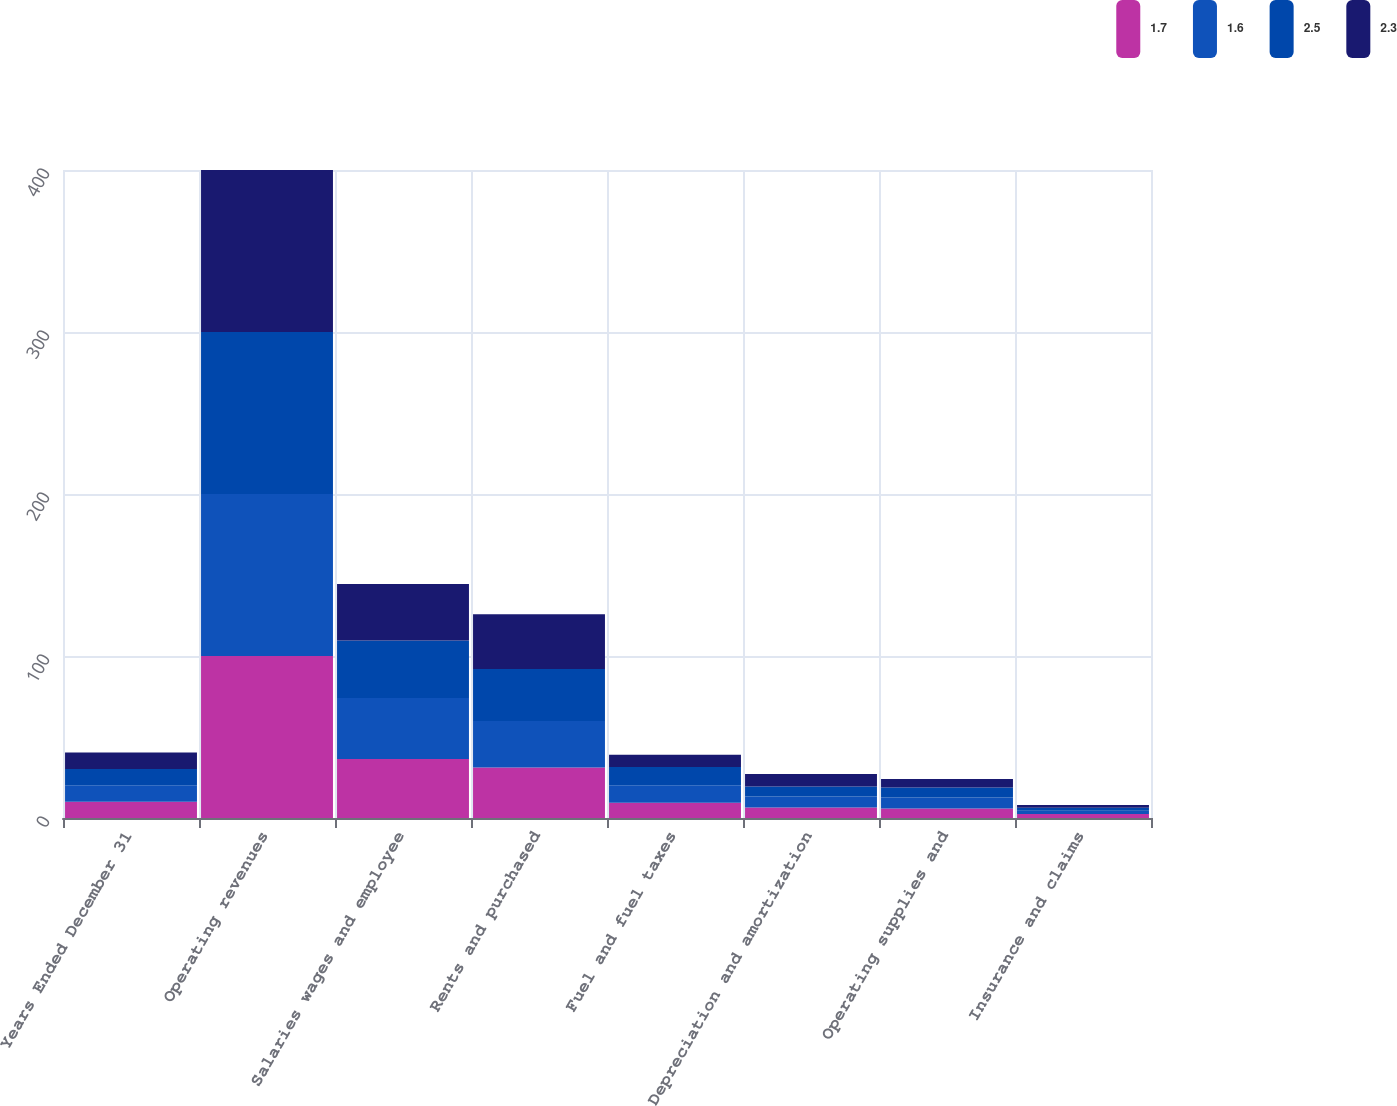<chart> <loc_0><loc_0><loc_500><loc_500><stacked_bar_chart><ecel><fcel>Years Ended December 31<fcel>Operating revenues<fcel>Salaries wages and employee<fcel>Rents and purchased<fcel>Fuel and fuel taxes<fcel>Depreciation and amortization<fcel>Operating supplies and<fcel>Insurance and claims<nl><fcel>1.7<fcel>10.1<fcel>100<fcel>36.4<fcel>31.1<fcel>9.4<fcel>6.5<fcel>5.8<fcel>2.5<nl><fcel>1.6<fcel>10.1<fcel>100<fcel>37.6<fcel>28.8<fcel>10.8<fcel>6.8<fcel>6.9<fcel>2<nl><fcel>2.5<fcel>10.1<fcel>100<fcel>35.6<fcel>32.1<fcel>11.3<fcel>6.2<fcel>6.1<fcel>1.8<nl><fcel>2.3<fcel>10.1<fcel>100<fcel>34.9<fcel>33.7<fcel>7.5<fcel>7.6<fcel>5.3<fcel>1.8<nl></chart> 